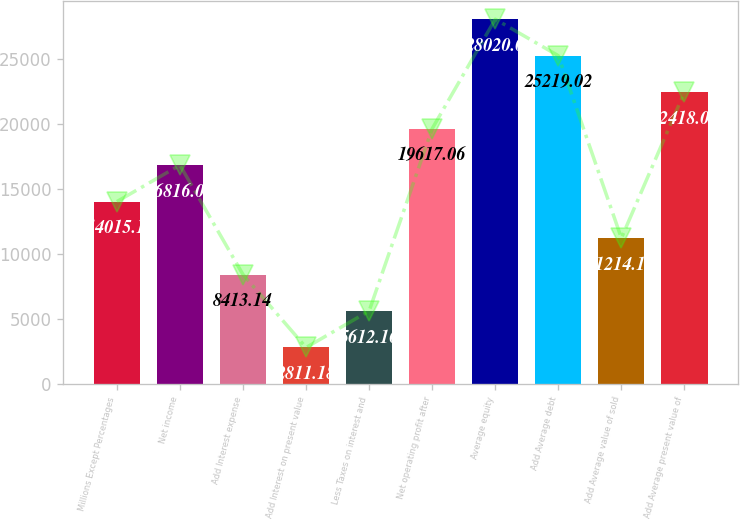Convert chart to OTSL. <chart><loc_0><loc_0><loc_500><loc_500><bar_chart><fcel>Millions Except Percentages<fcel>Net income<fcel>Add Interest expense<fcel>Add Interest on present value<fcel>Less Taxes on interest and<fcel>Net operating profit after<fcel>Average equity<fcel>Add Average debt<fcel>Add Average value of sold<fcel>Add Average present value of<nl><fcel>14015.1<fcel>16816.1<fcel>8413.14<fcel>2811.18<fcel>5612.16<fcel>19617.1<fcel>28020<fcel>25219<fcel>11214.1<fcel>22418<nl></chart> 